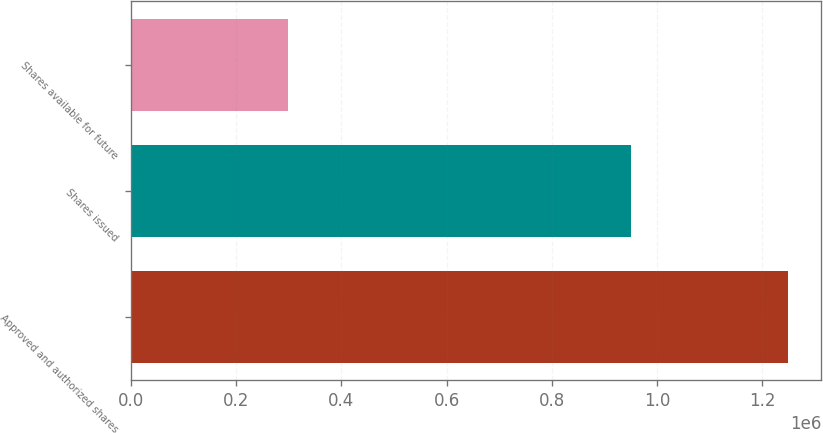Convert chart to OTSL. <chart><loc_0><loc_0><loc_500><loc_500><bar_chart><fcel>Approved and authorized shares<fcel>Shares issued<fcel>Shares available for future<nl><fcel>1.25e+06<fcel>951285<fcel>298715<nl></chart> 